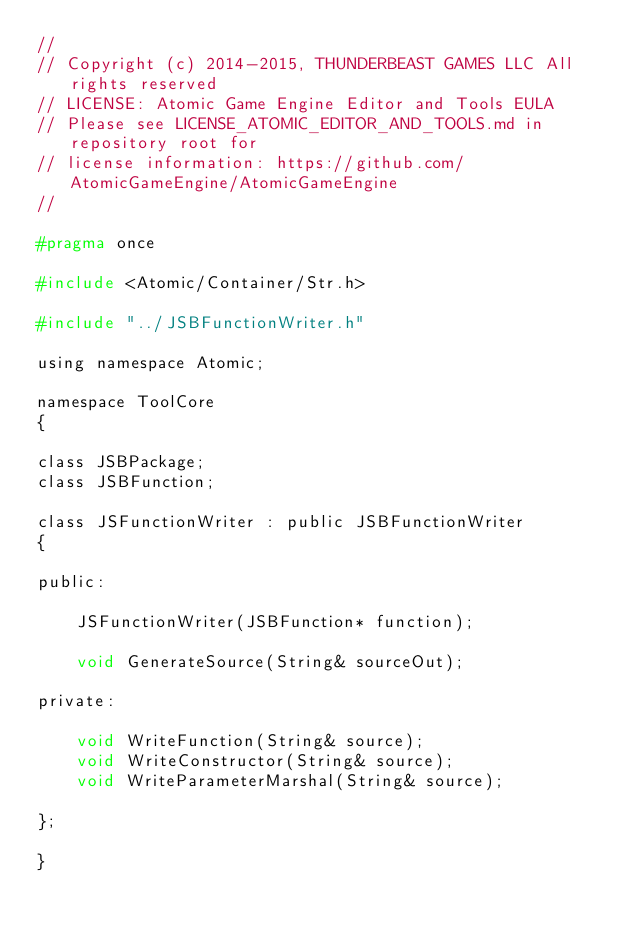<code> <loc_0><loc_0><loc_500><loc_500><_C_>//
// Copyright (c) 2014-2015, THUNDERBEAST GAMES LLC All rights reserved
// LICENSE: Atomic Game Engine Editor and Tools EULA
// Please see LICENSE_ATOMIC_EDITOR_AND_TOOLS.md in repository root for
// license information: https://github.com/AtomicGameEngine/AtomicGameEngine
//

#pragma once

#include <Atomic/Container/Str.h>

#include "../JSBFunctionWriter.h"

using namespace Atomic;

namespace ToolCore
{

class JSBPackage;
class JSBFunction;

class JSFunctionWriter : public JSBFunctionWriter
{

public:

    JSFunctionWriter(JSBFunction* function);

    void GenerateSource(String& sourceOut);

private:

    void WriteFunction(String& source);
    void WriteConstructor(String& source);
    void WriteParameterMarshal(String& source);

};

}
</code> 